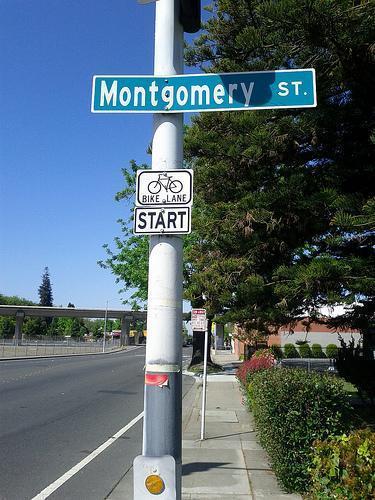How many signs are on the signpost?
Give a very brief answer. 3. How many bridges are in the photo?
Give a very brief answer. 1. 